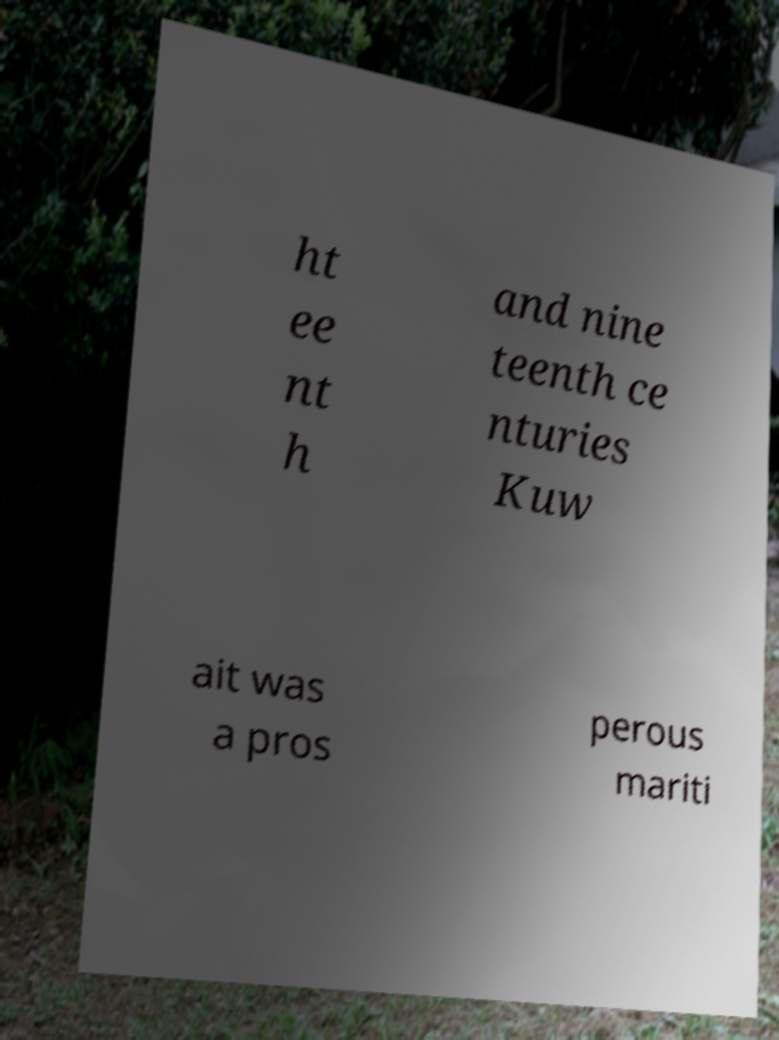Can you accurately transcribe the text from the provided image for me? ht ee nt h and nine teenth ce nturies Kuw ait was a pros perous mariti 